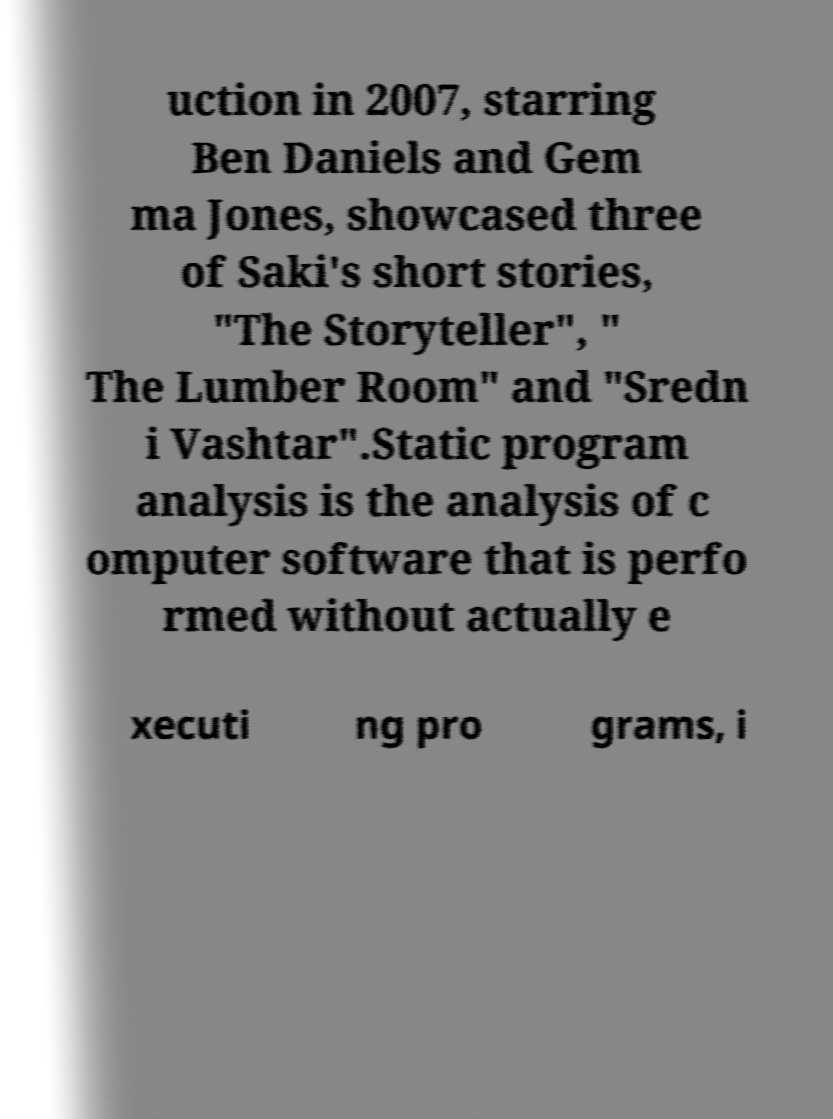What messages or text are displayed in this image? I need them in a readable, typed format. uction in 2007, starring Ben Daniels and Gem ma Jones, showcased three of Saki's short stories, "The Storyteller", " The Lumber Room" and "Sredn i Vashtar".Static program analysis is the analysis of c omputer software that is perfo rmed without actually e xecuti ng pro grams, i 